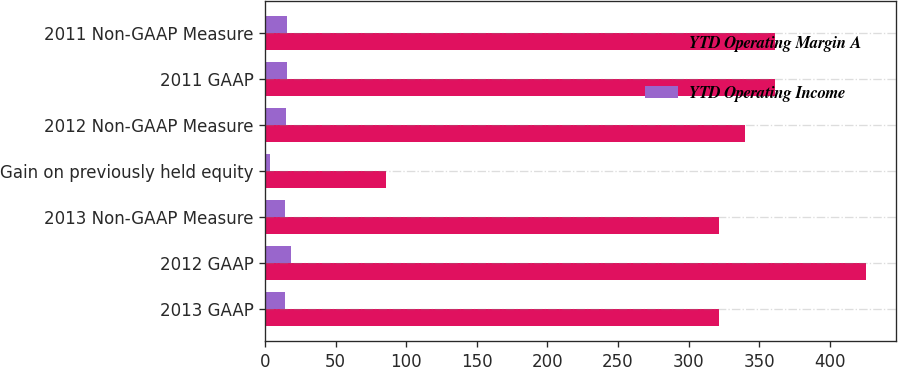Convert chart. <chart><loc_0><loc_0><loc_500><loc_500><stacked_bar_chart><ecel><fcel>2013 GAAP<fcel>2012 GAAP<fcel>2013 Non-GAAP Measure<fcel>Gain on previously held equity<fcel>2012 Non-GAAP Measure<fcel>2011 GAAP<fcel>2011 Non-GAAP Measure<nl><fcel>YTD Operating Margin A<fcel>321.3<fcel>425.6<fcel>321.3<fcel>85.9<fcel>339.7<fcel>361.1<fcel>361.1<nl><fcel>YTD Operating Income<fcel>14.3<fcel>18.3<fcel>14.3<fcel>3.7<fcel>14.6<fcel>15.8<fcel>15.8<nl></chart> 